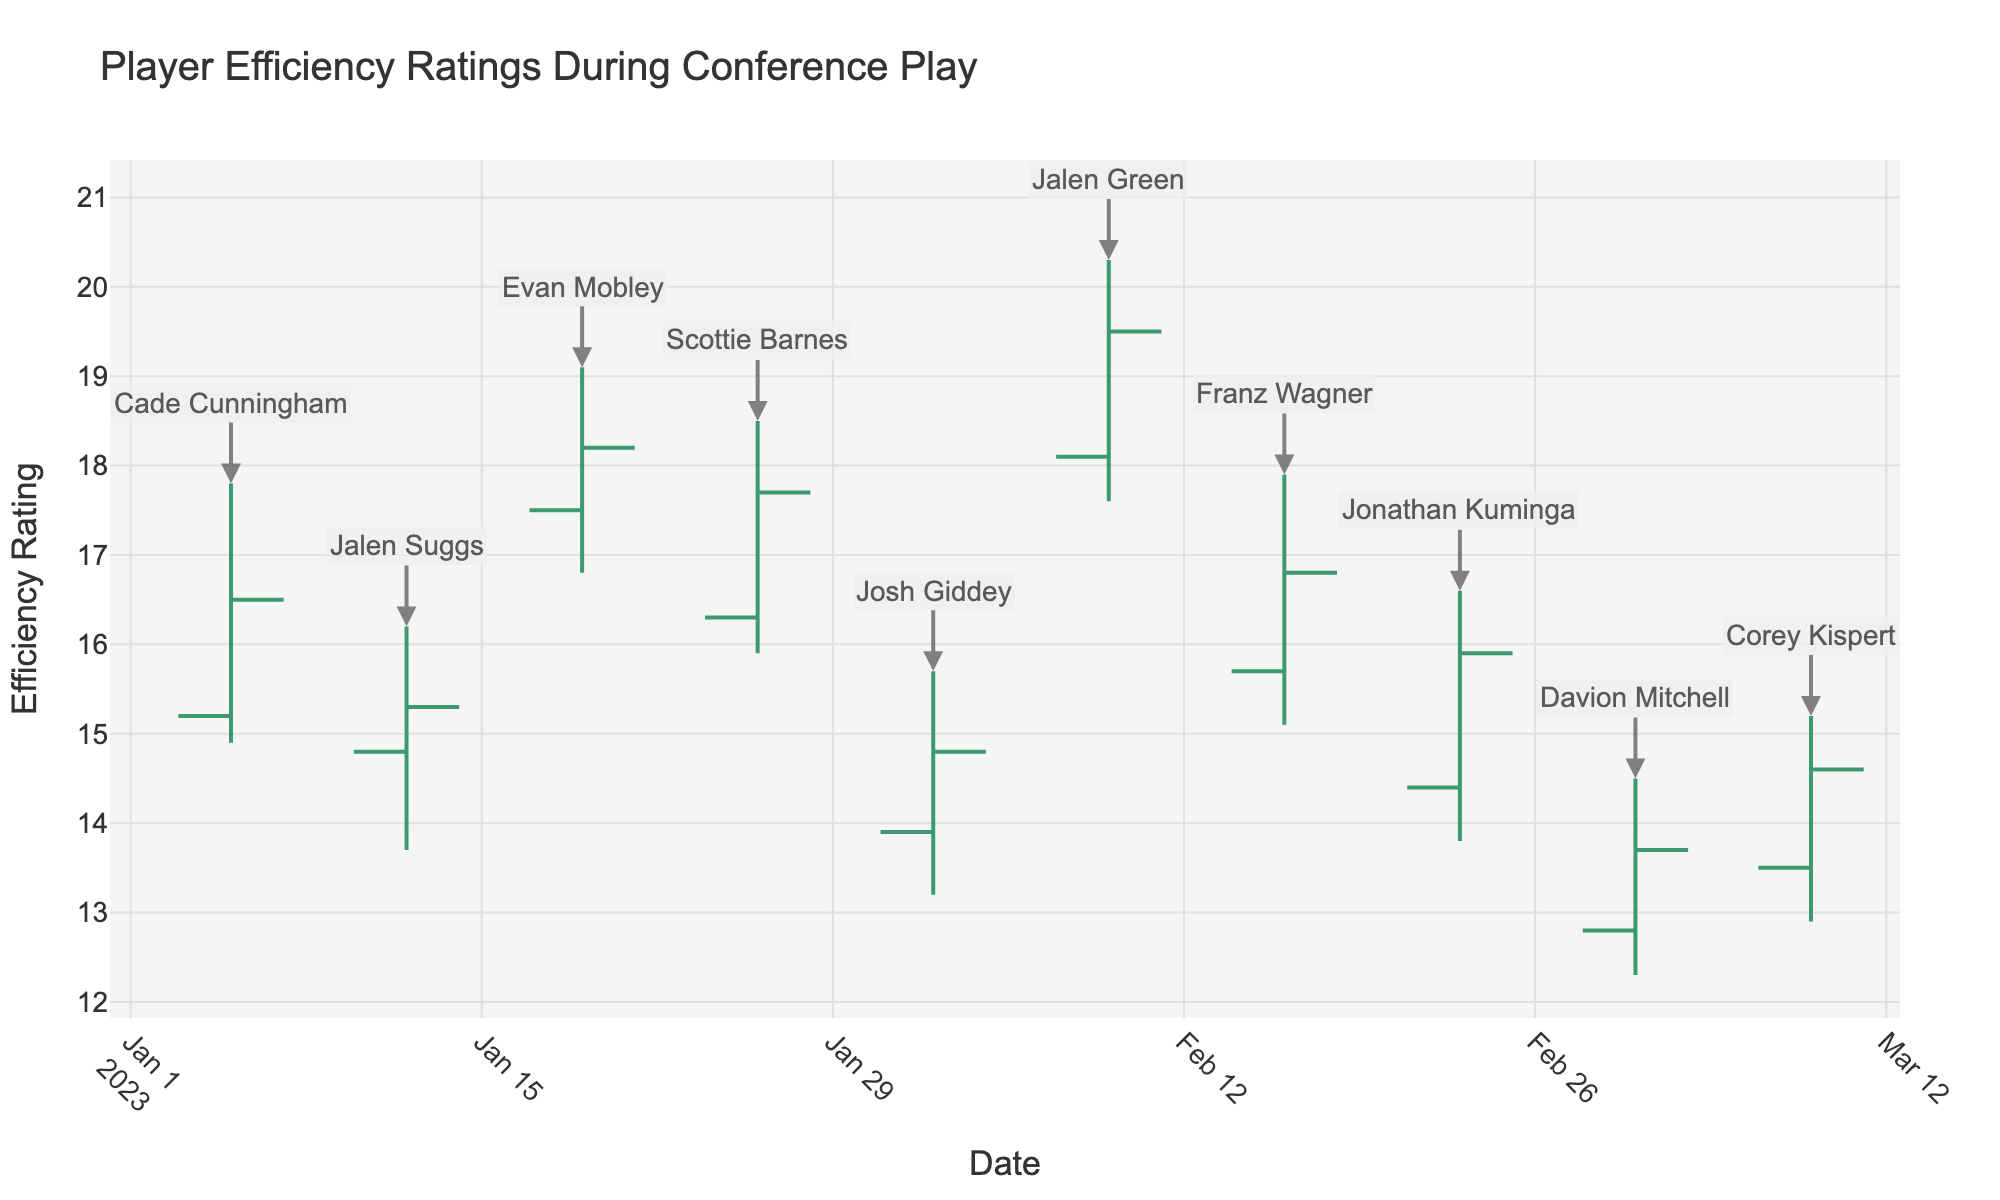What's the title of the chart? The title of the chart is displayed at the top and reads "Player Efficiency Ratings During Conference Play".
Answer: Player Efficiency Ratings During Conference Play What is the highest efficiency rating reached by any player and who achieved it? The highest vertical point on any bar in the chart represents the highest efficiency rating. For Jalen Green on February 9, the high value is 20.3.
Answer: 20.3, Jalen Green Which player has the lowest closing efficiency rating? The closing efficiency rating is indicated by the shorter horizontal line on the right side of each bar. Davion Mitchell has the lowest closing efficiency rating, which is 13.7, on March 2.
Answer: Davion Mitchell Compare the performance of Cade Cunningham and Jalen Suggs. Who had a higher increase from open to close? For Cade Cunningham, the open and close values are 15.2 and 16.5, respectively (difference: 1.3). For Jalen Suggs, the open and close values are 14.8 and 15.3, respectively (difference: 0.5). Therefore, Cade Cunningham had a higher increase.
Answer: Cade Cunningham What is the average high value of all players? The high values of all players are: 17.8, 16.2, 19.1, 18.5, 15.7, 20.3, 17.9, 16.6, 14.5, 15.2. The sum is 171.8 and there are 10 players, so the average is 171.8 / 10 = 17.18.
Answer: 17.18 Which player showed the most significant drop in efficiency from their high to their low, and what are the values? To find the most significant drop, calculate the difference between the high and low values for each player. Jalen Green had the highest drop: 20.3 (high) - 17.6 (low) = 2.7.
Answer: Jalen Green, 20.3 (high) and 17.6 (low) On which date did the player with the highest closing efficiency rating achieve it? The highest closing efficiency rating can be determined by looking at the end of each bar to the right. Jalen Green's closing rating on February 9 is the highest at 19.5.
Answer: February 9 What is the range of efficiency ratings for Scottie Barnes? The range is the difference between the high and low values. For Scottie Barnes: 18.5 (high) - 15.9 (low) = 2.6.
Answer: 2.6 Who had a lower opening efficiency rating on February 23rd compared to March 2nd, and what were the values for both dates? Compare Jonathan Kuminga's rating on February 23 (opening 14.4) with Davion Mitchell's on March 2 (opening 12.8). Jonathan Kuminga has the lower opening rating on February 23.
Answer: Jonathan Kuminga, 14.4 (Feb 23) and 12.8 (Mar 2) How did Franz Wagner's performance change from his opening to closing ratings? Franz Wagner's opening rating is 15.7 and closing rating is 16.8. The change is calculated as 16.8 - 15.7 = 1.1.
Answer: Increased by 1.1 